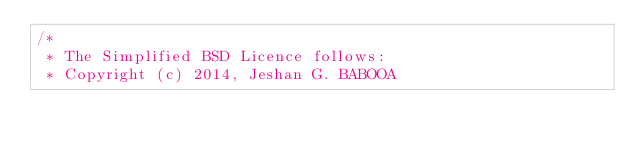Convert code to text. <code><loc_0><loc_0><loc_500><loc_500><_Scala_>/*
 * The Simplified BSD Licence follows:
 * Copyright (c) 2014, Jeshan G. BABOOA</code> 